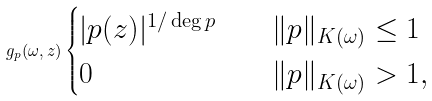<formula> <loc_0><loc_0><loc_500><loc_500>g _ { p } ( \omega , z ) \begin{cases} | p ( z ) | ^ { 1 / \deg p } & \quad \| p \| _ { K ( \omega ) } \leq 1 \\ 0 & \quad \| p \| _ { K ( \omega ) } > 1 , \\ \end{cases}</formula> 